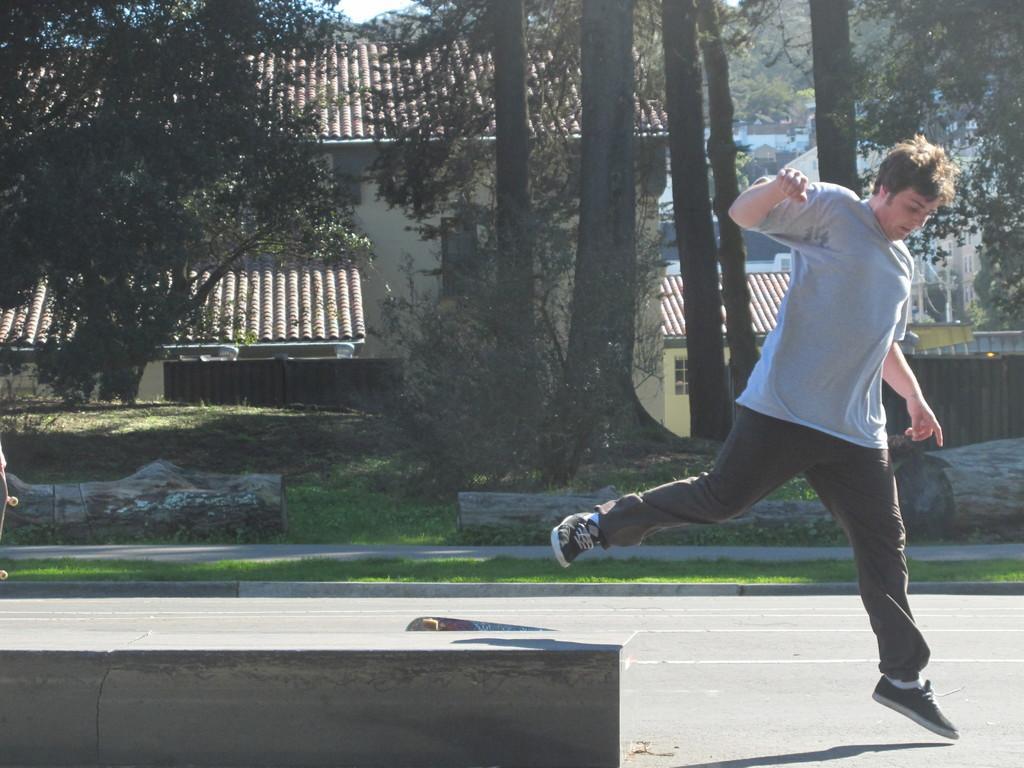Please provide a concise description of this image. In the image we can see a person wearing clothes and shoes. There is a skateboard, road, grass, trees, building and a sky. 